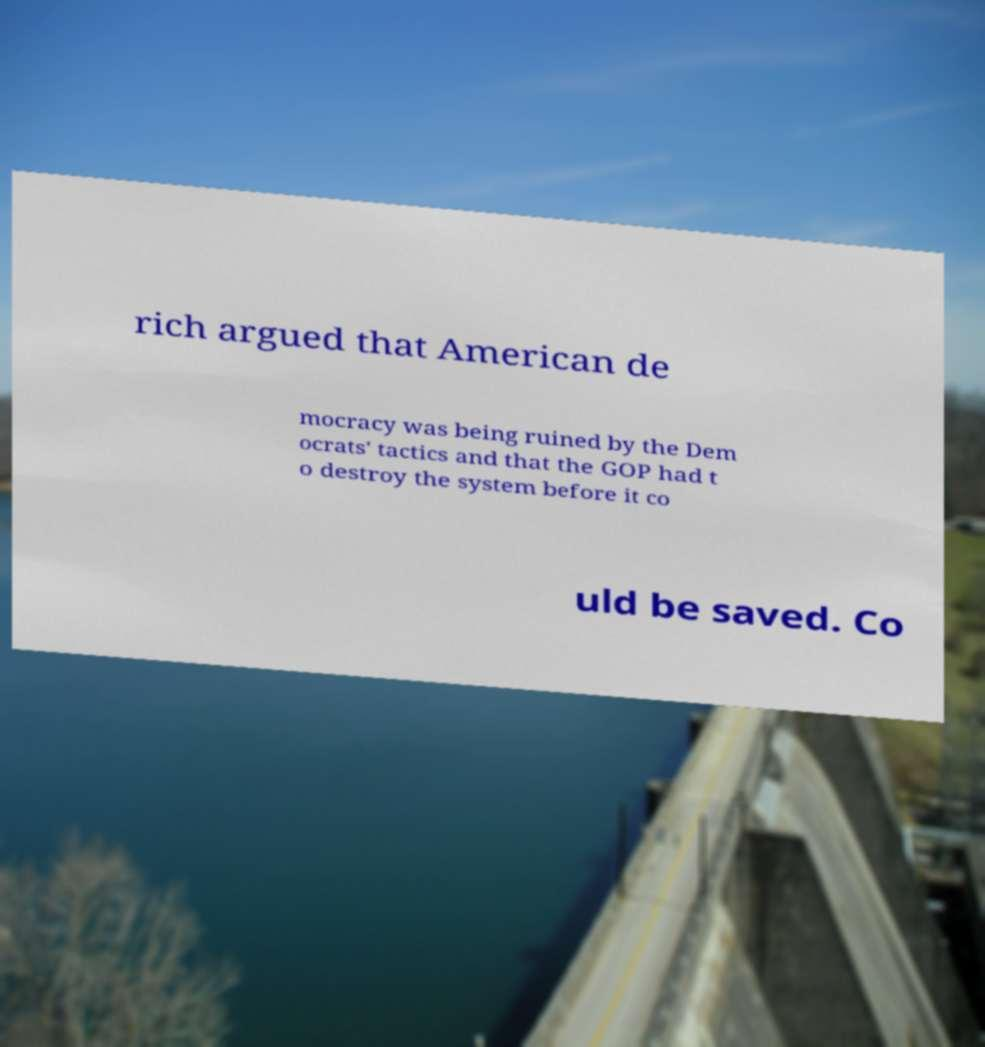Can you accurately transcribe the text from the provided image for me? rich argued that American de mocracy was being ruined by the Dem ocrats' tactics and that the GOP had t o destroy the system before it co uld be saved. Co 